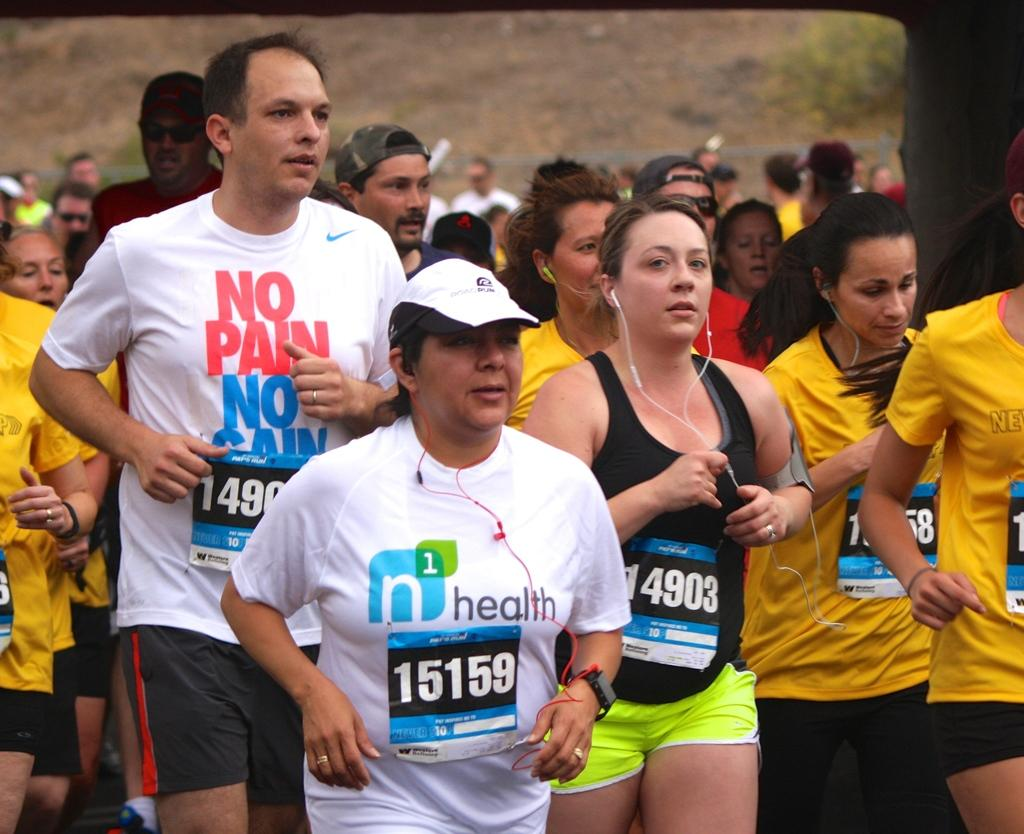What are the persons in the image doing? There is a group of persons running in the image. What else can be seen in the image besides the running persons? There are wires visible in the image, and there is an object towards the right side of the image. Is there any vegetation present in the image? Yes, there is a plant on the ground towards the top of the image. What type of jelly is being served to the committee in the image? There is no jelly or committee present in the image. What is the value of the object on the right side of the image? The value of the object cannot be determined from the image, as it is not mentioned in the provided facts. 